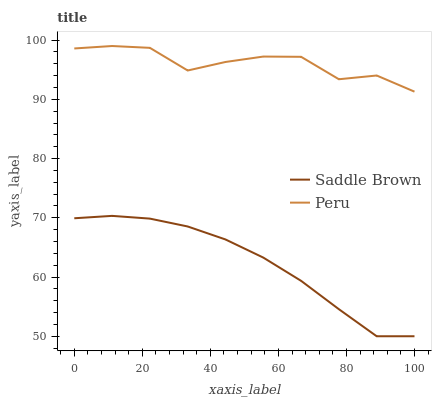Does Saddle Brown have the minimum area under the curve?
Answer yes or no. Yes. Does Peru have the maximum area under the curve?
Answer yes or no. Yes. Does Peru have the minimum area under the curve?
Answer yes or no. No. Is Saddle Brown the smoothest?
Answer yes or no. Yes. Is Peru the roughest?
Answer yes or no. Yes. Is Peru the smoothest?
Answer yes or no. No. Does Saddle Brown have the lowest value?
Answer yes or no. Yes. Does Peru have the lowest value?
Answer yes or no. No. Does Peru have the highest value?
Answer yes or no. Yes. Is Saddle Brown less than Peru?
Answer yes or no. Yes. Is Peru greater than Saddle Brown?
Answer yes or no. Yes. Does Saddle Brown intersect Peru?
Answer yes or no. No. 